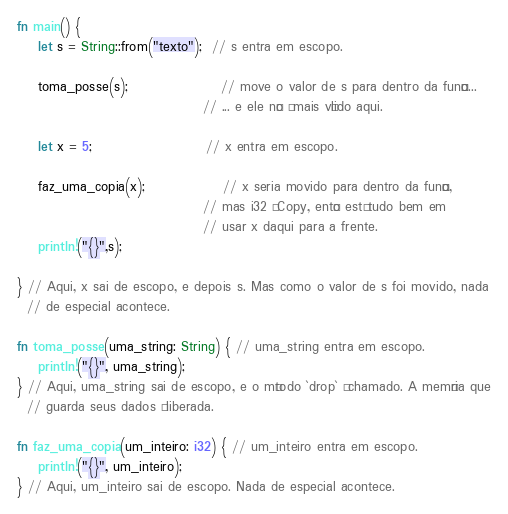Convert code to text. <code><loc_0><loc_0><loc_500><loc_500><_Rust_>fn main() {
    let s = String::from("texto");  // s entra em escopo.

    toma_posse(s);                  // move o valor de s para dentro da função...
                                    // ... e ele não é mais válido aqui.

    let x = 5;                      // x entra em escopo.

    faz_uma_copia(x);               // x seria movido para dentro da função,
                                    // mas i32 é Copy, então está tudo bem em
                                    // usar x daqui para a frente.
    println!("{}",s);

} // Aqui, x sai de escopo, e depois s. Mas como o valor de s foi movido, nada
  // de especial acontece.

fn toma_posse(uma_string: String) { // uma_string entra em escopo.
    println!("{}", uma_string);
} // Aqui, uma_string sai de escopo, e o método `drop` é chamado. A memória que
  // guarda seus dados é liberada.

fn faz_uma_copia(um_inteiro: i32) { // um_inteiro entra em escopo.
    println!("{}", um_inteiro);
} // Aqui, um_inteiro sai de escopo. Nada de especial acontece.
</code> 